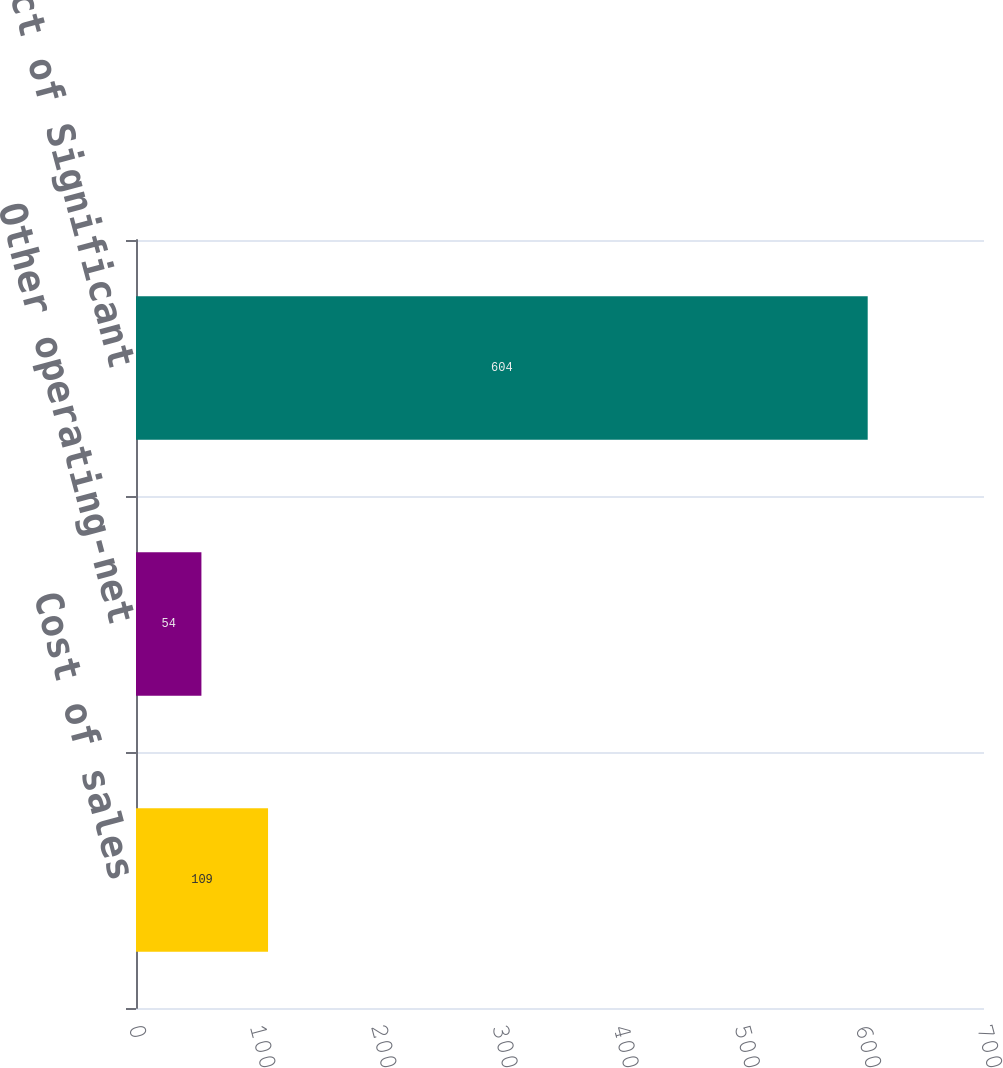Convert chart. <chart><loc_0><loc_0><loc_500><loc_500><bar_chart><fcel>Cost of sales<fcel>Other operating-net<fcel>Total Impact of Significant<nl><fcel>109<fcel>54<fcel>604<nl></chart> 